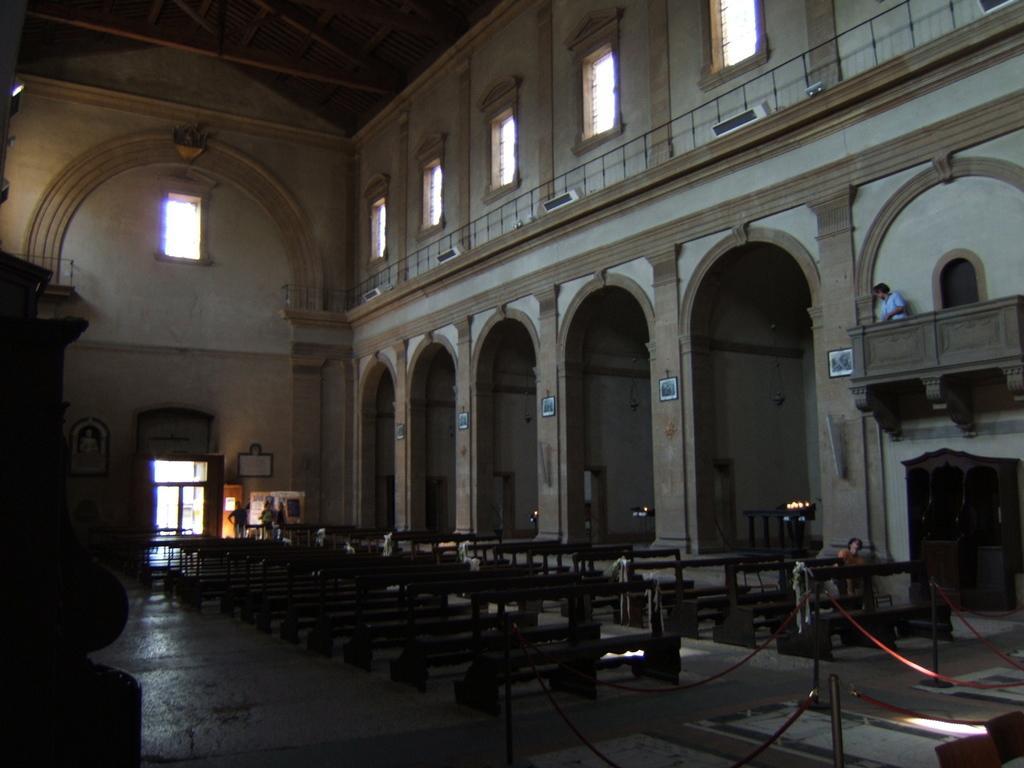Please provide a concise description of this image. In this image there are benches. There are safety poles with ribbon. To the right side of the image there are pillars. There is a person standing in balcony. In the background of the image there is wall. There is a door. At the bottom of the image there is floor. At the top of the image there is ceiling. To the right side of the image there are windows. 